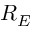<formula> <loc_0><loc_0><loc_500><loc_500>R _ { E }</formula> 